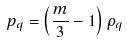<formula> <loc_0><loc_0><loc_500><loc_500>p _ { q } = \left ( \frac { m } { 3 } - 1 \right ) \rho _ { q }</formula> 